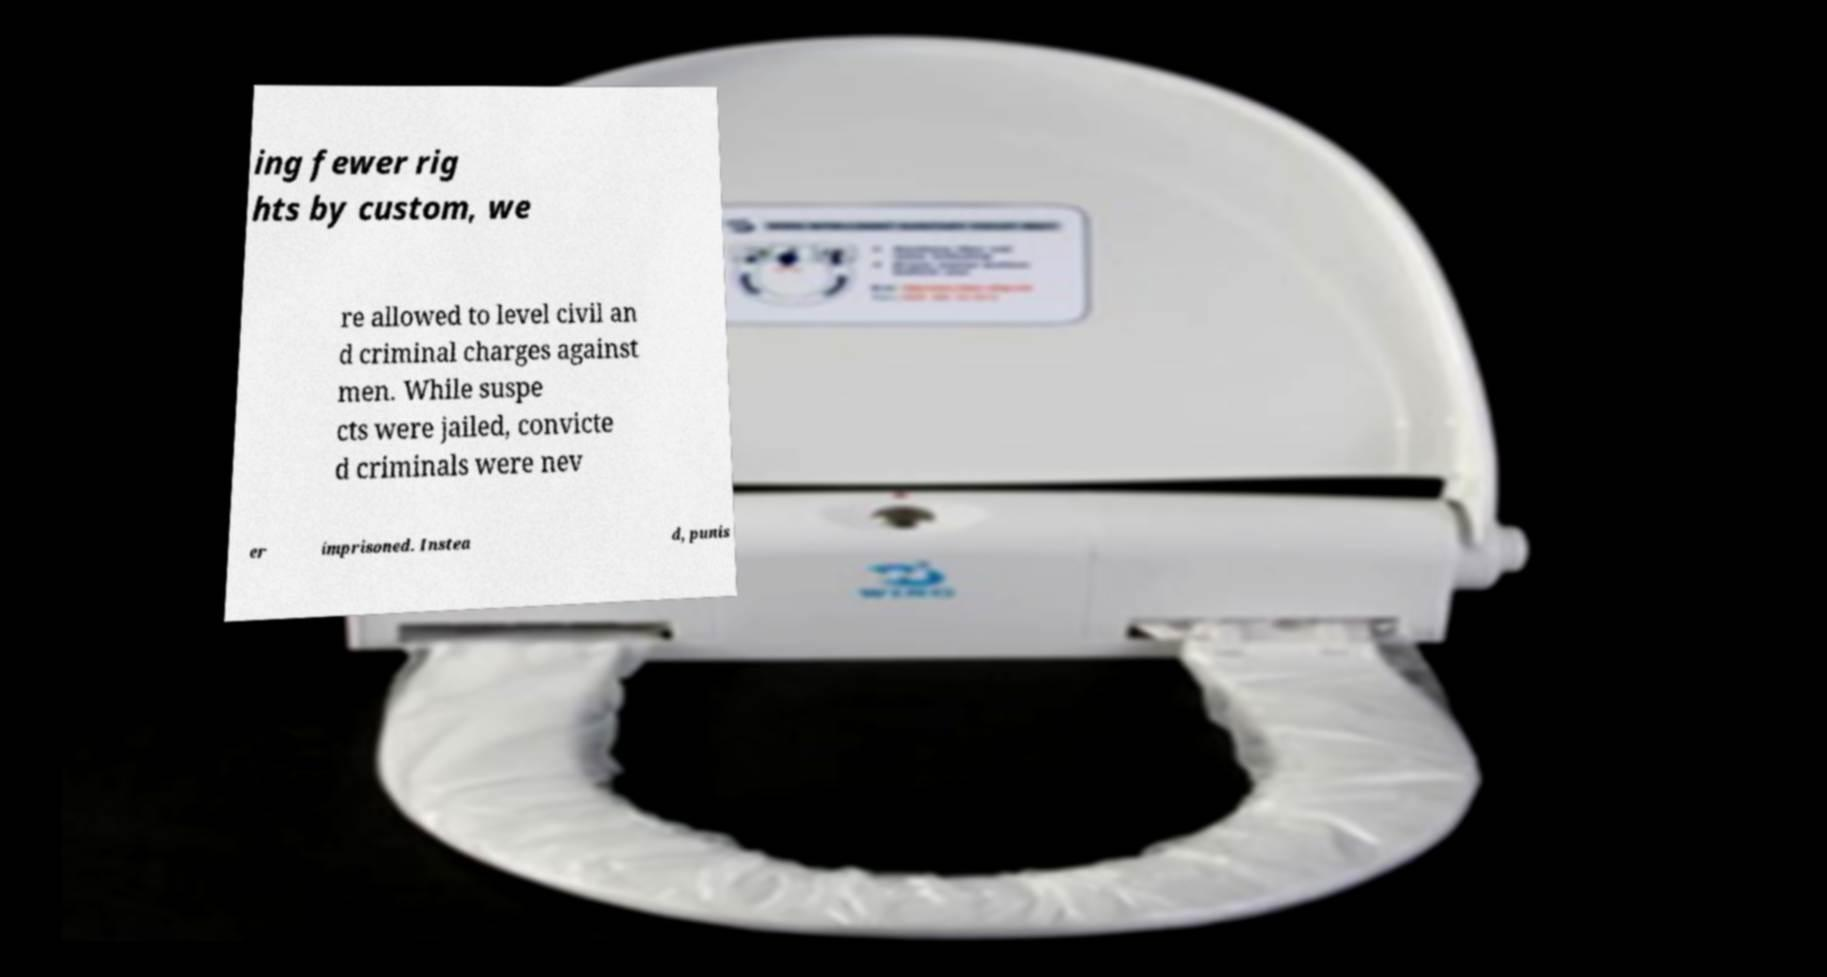Could you assist in decoding the text presented in this image and type it out clearly? ing fewer rig hts by custom, we re allowed to level civil an d criminal charges against men. While suspe cts were jailed, convicte d criminals were nev er imprisoned. Instea d, punis 